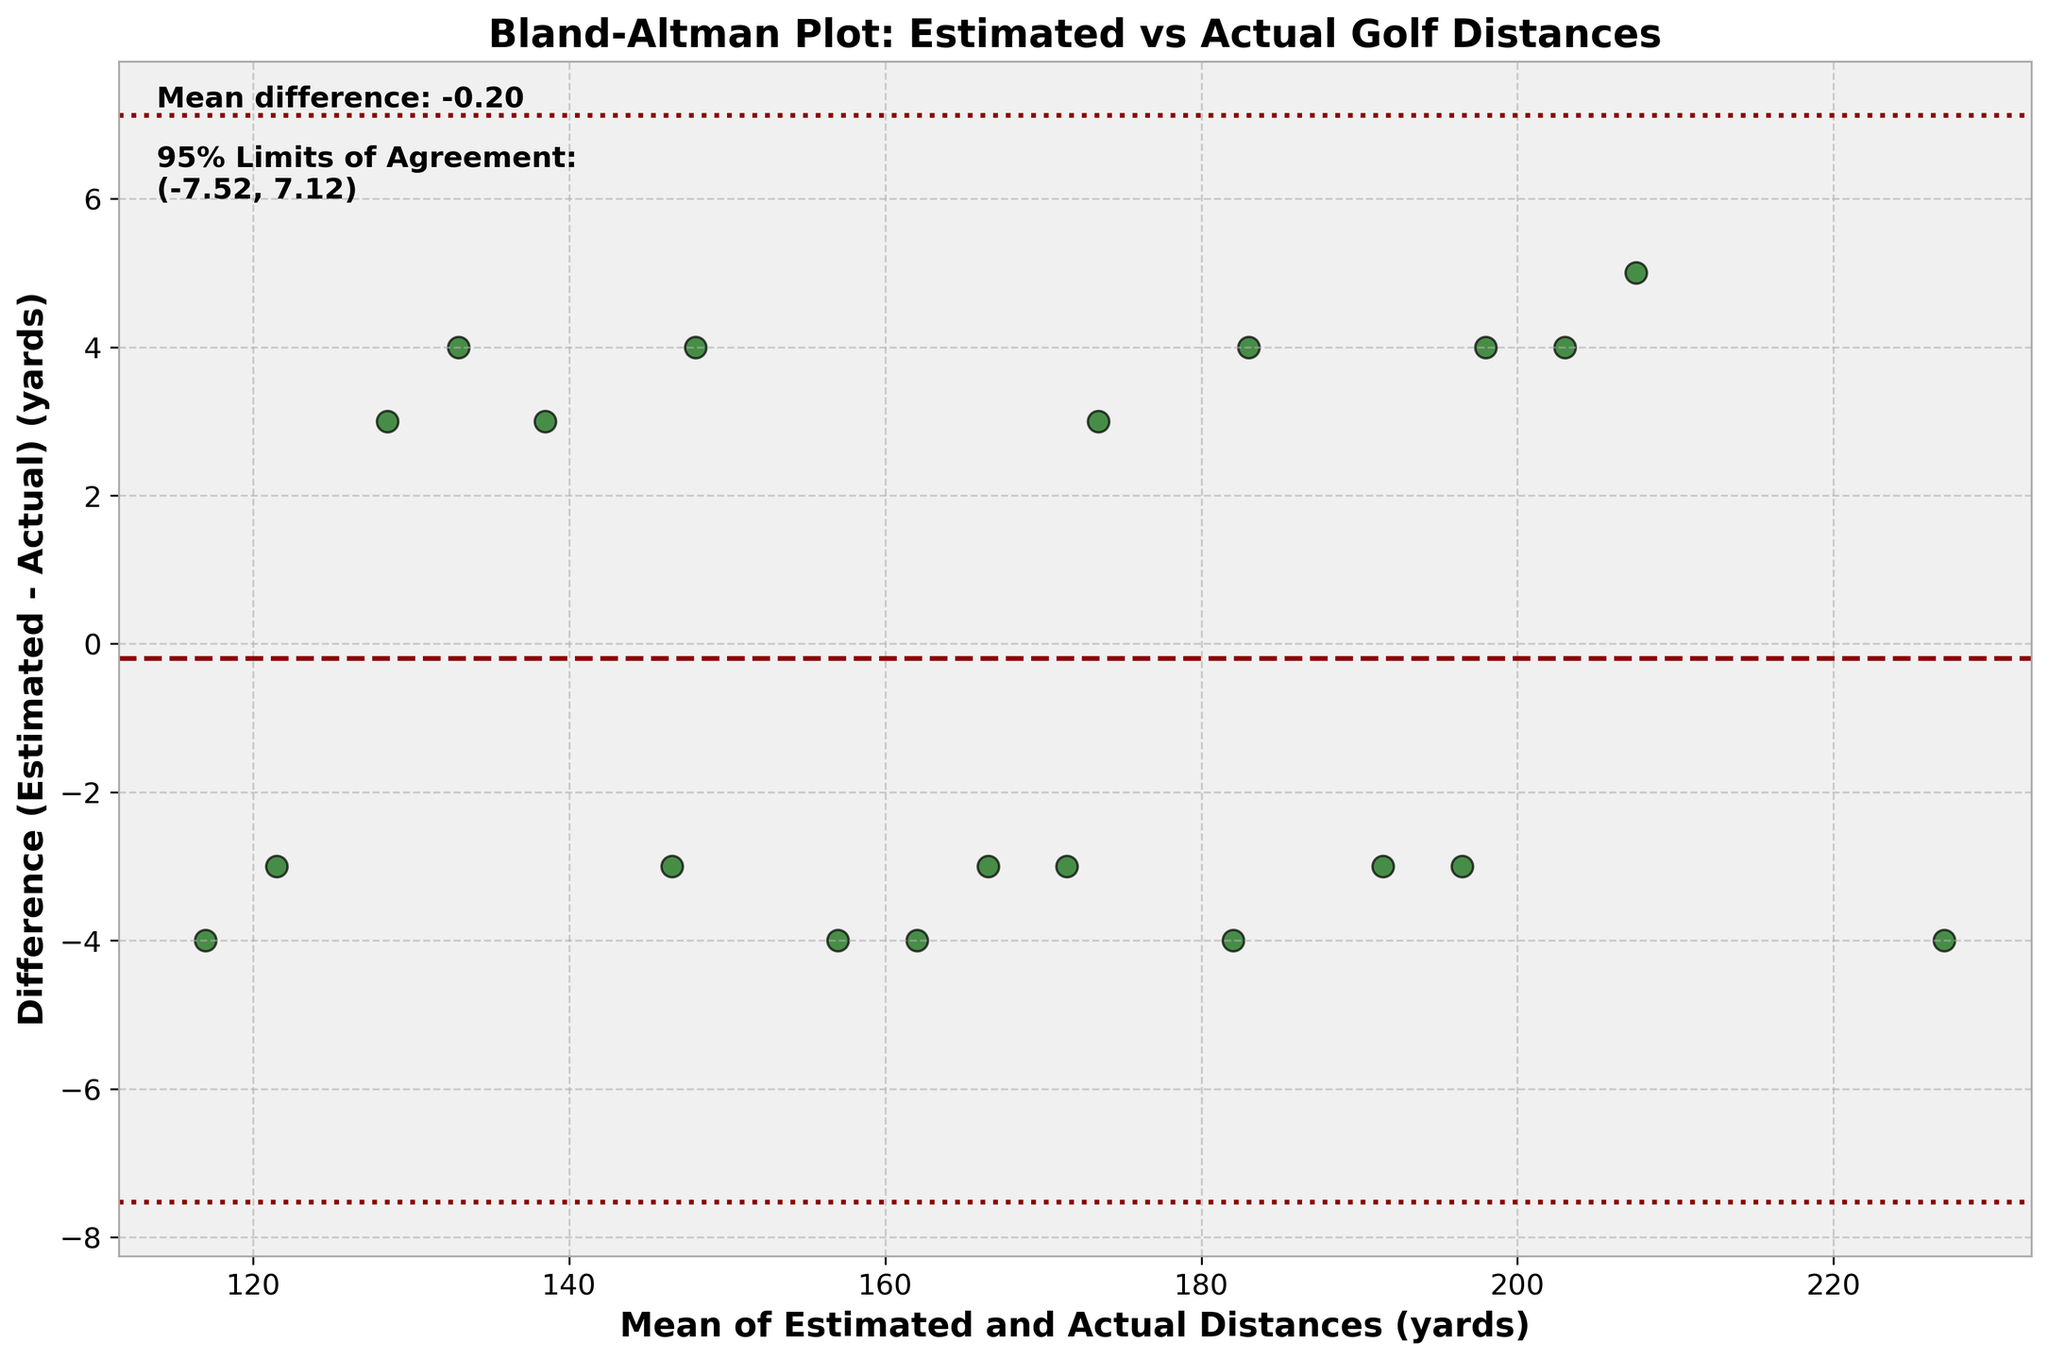How many data points are shown in the scatter plot? To determine the number of data points, count the individual scatter points on the plot.
Answer: 20 What is the main title of the plot? The main title of the plot is usually located at the top of the plot and identifies the purpose or subject.
Answer: Bland-Altman Plot: Estimated vs Actual Golf Distances What are the units used for the x-axis and y-axis? The plot's x-axis represents the mean of estimated and actual distances in yards, and the y-axis represents the difference between estimated and actual distances in yards.
Answer: yards What is the mean difference between the estimated and actual distances? Find the horizontal dashed line that marks the mean difference and read the value from the text annotation on the plot.
Answer: ~ -0.95 yards What are the 95% limits of agreement displayed in the plot? The 95% limits of agreement are shown as two horizontal dotted lines. The values are provided in the text annotation on the plot.
Answer: (~ -8.39, ~6.49) yards Which golfer's estimated distance is significantly under the actual distance when the mean distance is approximately 225 yards? Locate the points around the mean distance of 225 yards and find the one where the difference (Estimated - Actual) is most negative. This point corresponds to Bryson DeChambeau.
Answer: Bryson DeChambeau Is there any data point where the estimated distance perfectly matches the actual distance? Look for any data points on the scatter plot that lie exactly on the zero line of the y-axis, where the difference would be zero.
Answer: No What general trend do you observe in the differences as the mean distance increases? Analyze the scatter plot to see if there is a visible pattern in the differences (y-axis) as the mean distances (x-axis) increase. Notably, ascertain whether the differences cluster around the mean difference or spread out.
Answer: Differences are fairly consistent without any clear trend Which golfer had the smallest estimation error, and what was the distance? Identify the point closest to the zero line on the y-axis (difference = 0). Check its corresponding mean distance for accurate reference.
Answer: Jordan Spieth (Mean distance approximately 128.5 yards) What does the position of the mean difference line relative to zero suggest about the overall estimation of distances? Observe the mean difference line's position (dashed line) relative to the zero line to deduce whether estimations tend to be lower, higher, or balanced compared to the actual distances.
Answer: Estimations are slightly lower on average 